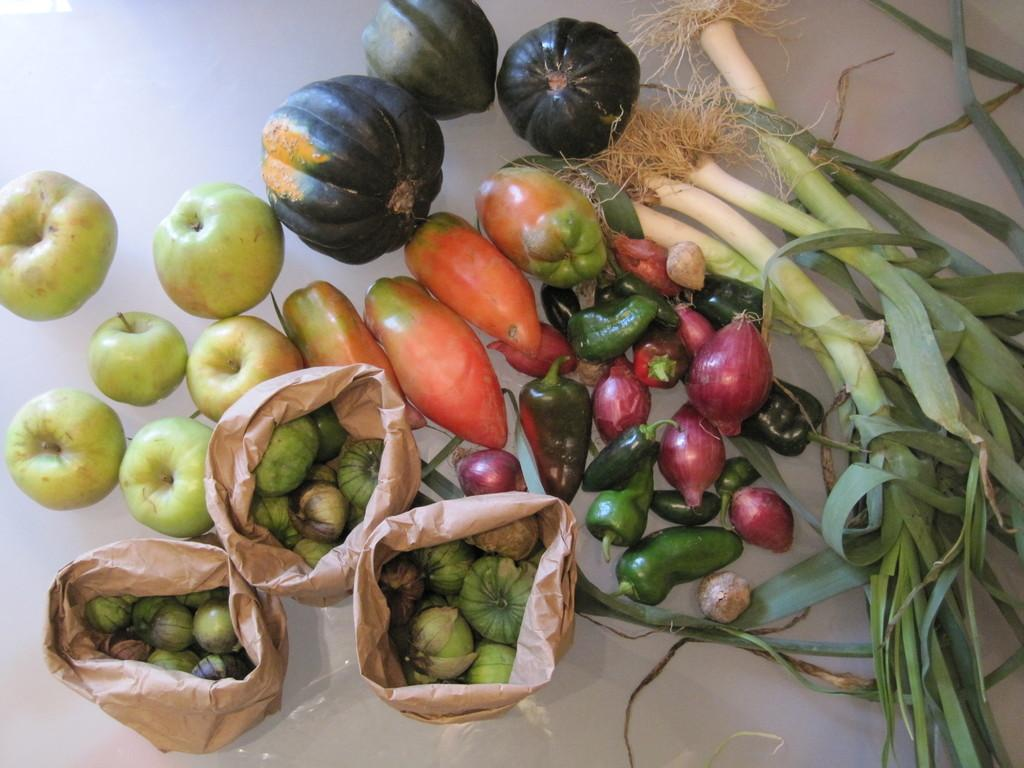What type of bags are visible in the image? There are paper bags in the image. What type of fruit is present in the image? There are apples in the image. What type of seasonal produce can be seen in the image? There are pumpkins in the image. What type of vegetable is present in the image? There are onions in the image. What other types of vegetables can be seen in the image? There are other vegetables in the image. What type of flower is being used as a treatment in the image? There is no flower or treatment present in the image. 